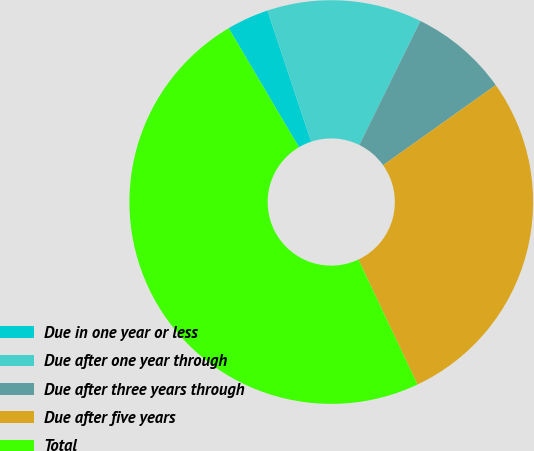Convert chart. <chart><loc_0><loc_0><loc_500><loc_500><pie_chart><fcel>Due in one year or less<fcel>Due after one year through<fcel>Due after three years through<fcel>Due after five years<fcel>Total<nl><fcel>3.37%<fcel>12.4%<fcel>7.88%<fcel>27.81%<fcel>48.54%<nl></chart> 